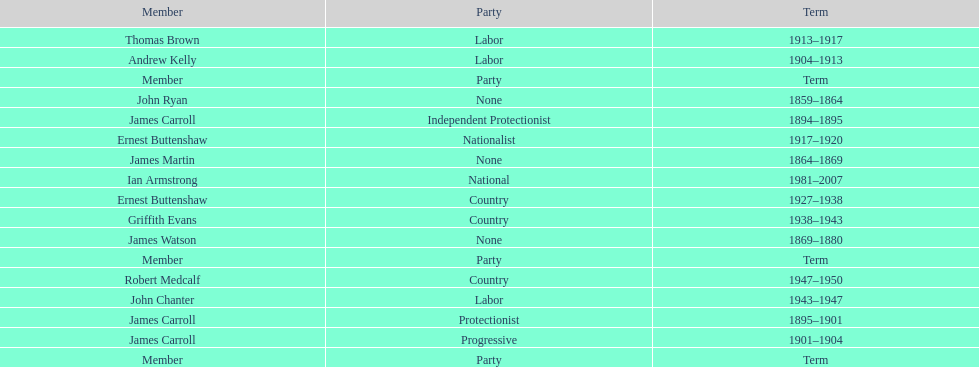How long did the fourth incarnation of the lachlan exist? 1981-2007. 